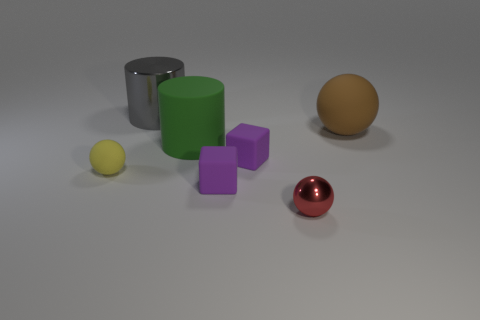Subtract all tiny balls. How many balls are left? 1 Subtract all red spheres. How many spheres are left? 2 Subtract 1 cylinders. How many cylinders are left? 1 Add 1 small things. How many objects exist? 8 Subtract all blocks. How many objects are left? 5 Subtract all purple balls. Subtract all yellow cylinders. How many balls are left? 3 Subtract all blue spheres. How many blue cylinders are left? 0 Subtract 0 cyan balls. How many objects are left? 7 Subtract all small metallic blocks. Subtract all large brown matte balls. How many objects are left? 6 Add 5 large gray shiny cylinders. How many large gray shiny cylinders are left? 6 